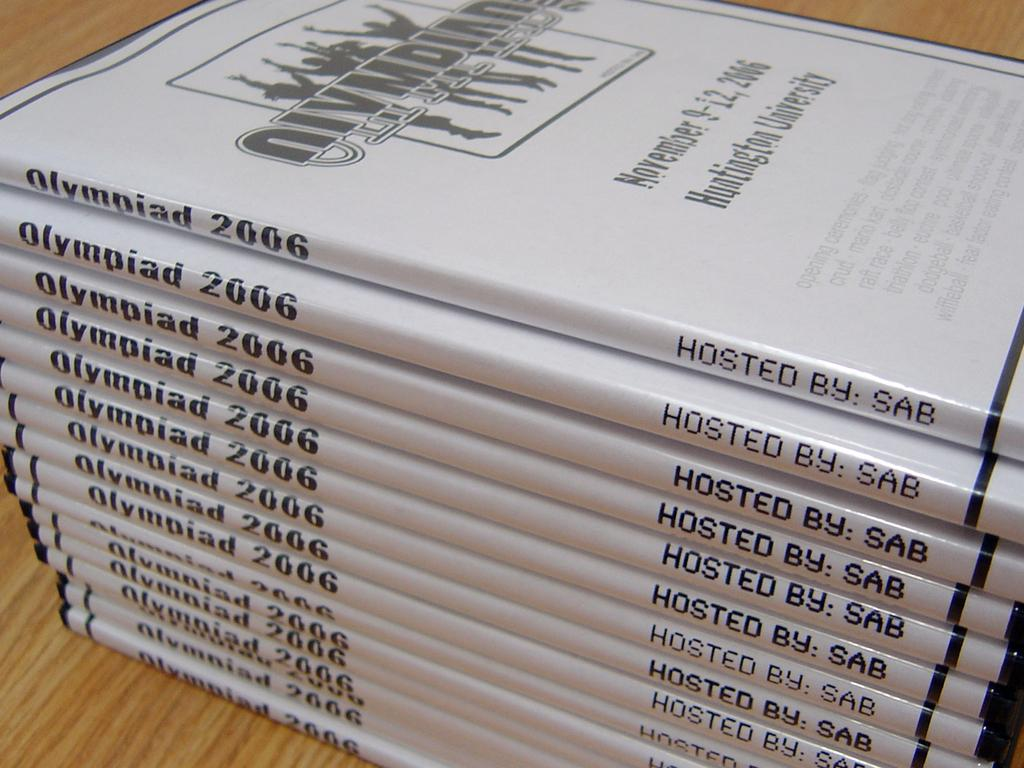What is the main object in the image? There is a table in the image. What is placed on the table? There is a group of books on the table. What type of plate is being used for the meeting in the image? There is no plate or meeting present in the image; it only features a table with a group of books. 